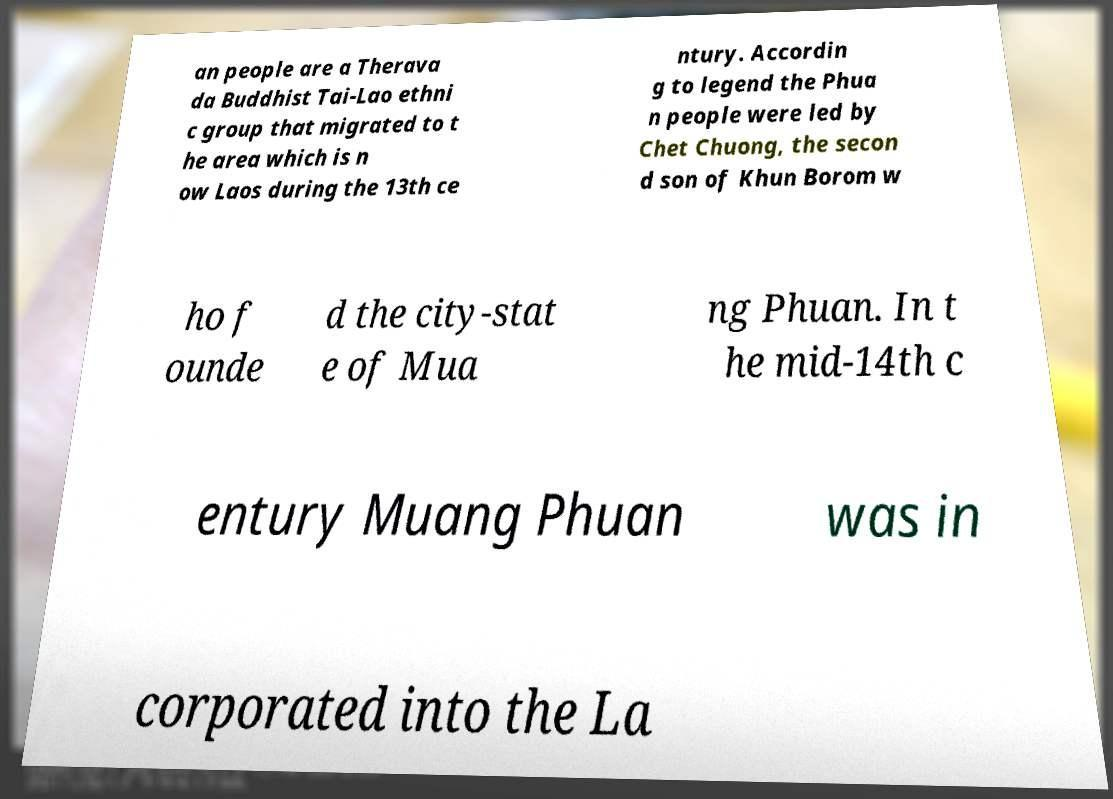I need the written content from this picture converted into text. Can you do that? an people are a Therava da Buddhist Tai-Lao ethni c group that migrated to t he area which is n ow Laos during the 13th ce ntury. Accordin g to legend the Phua n people were led by Chet Chuong, the secon d son of Khun Borom w ho f ounde d the city-stat e of Mua ng Phuan. In t he mid-14th c entury Muang Phuan was in corporated into the La 